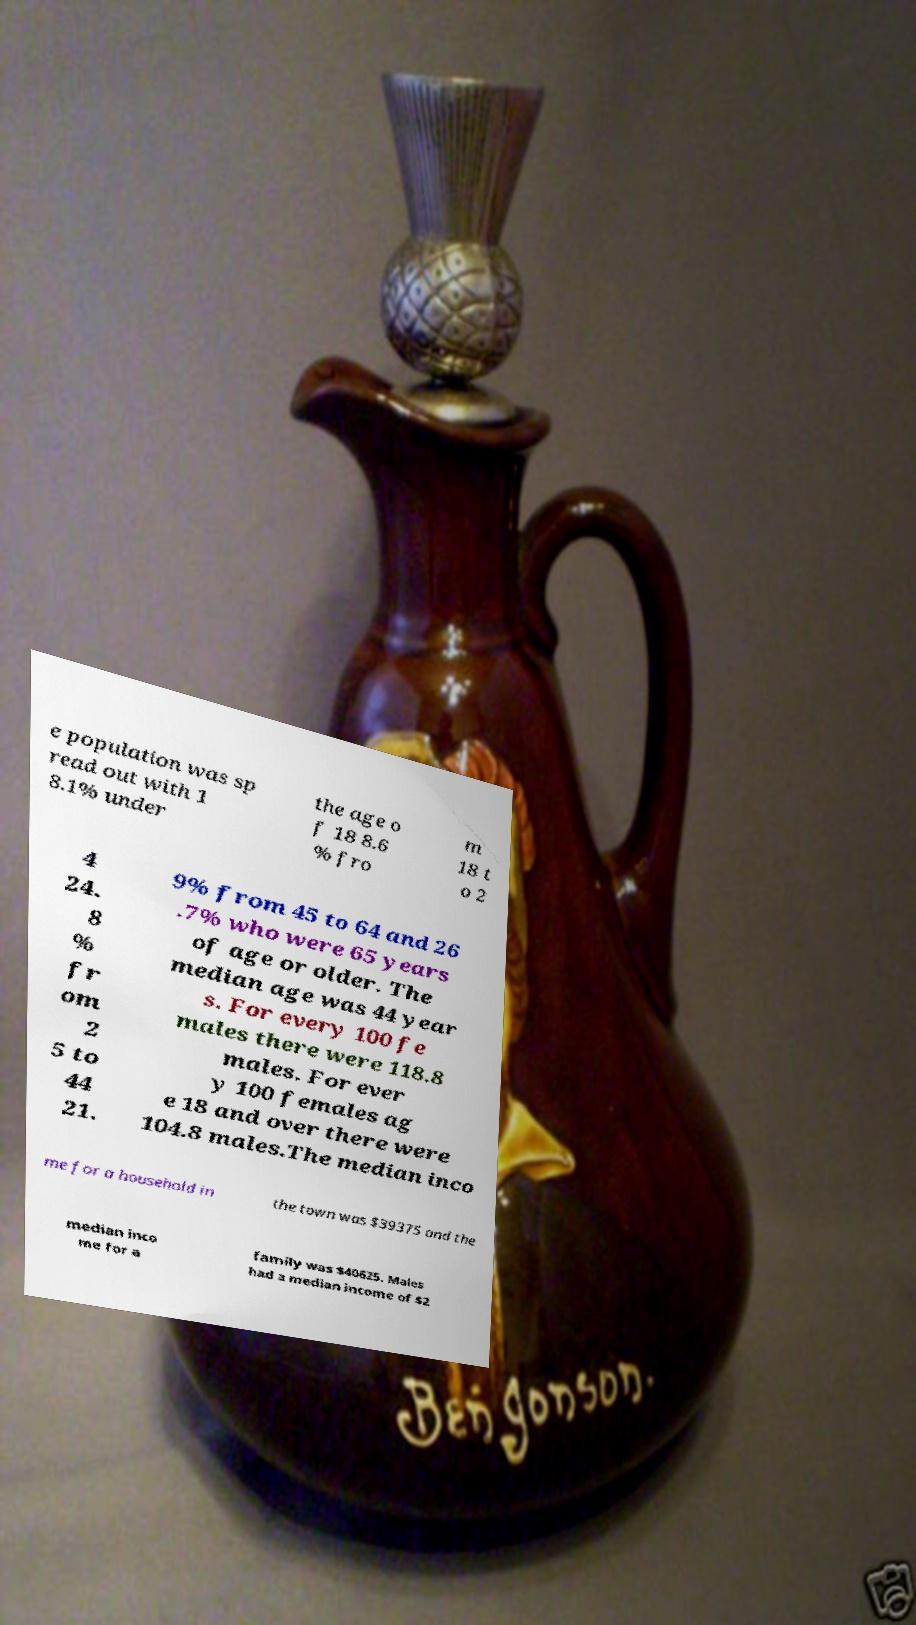Please read and relay the text visible in this image. What does it say? e population was sp read out with 1 8.1% under the age o f 18 8.6 % fro m 18 t o 2 4 24. 8 % fr om 2 5 to 44 21. 9% from 45 to 64 and 26 .7% who were 65 years of age or older. The median age was 44 year s. For every 100 fe males there were 118.8 males. For ever y 100 females ag e 18 and over there were 104.8 males.The median inco me for a household in the town was $39375 and the median inco me for a family was $40625. Males had a median income of $2 